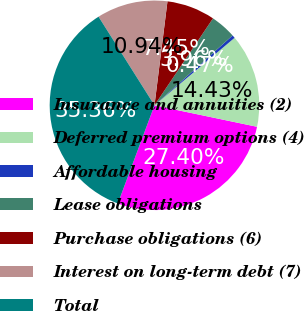Convert chart to OTSL. <chart><loc_0><loc_0><loc_500><loc_500><pie_chart><fcel>Insurance and annuities (2)<fcel>Deferred premium options (4)<fcel>Affordable housing<fcel>Lease obligations<fcel>Purchase obligations (6)<fcel>Interest on long-term debt (7)<fcel>Total<nl><fcel>27.4%<fcel>14.43%<fcel>0.47%<fcel>3.96%<fcel>7.45%<fcel>10.94%<fcel>35.36%<nl></chart> 